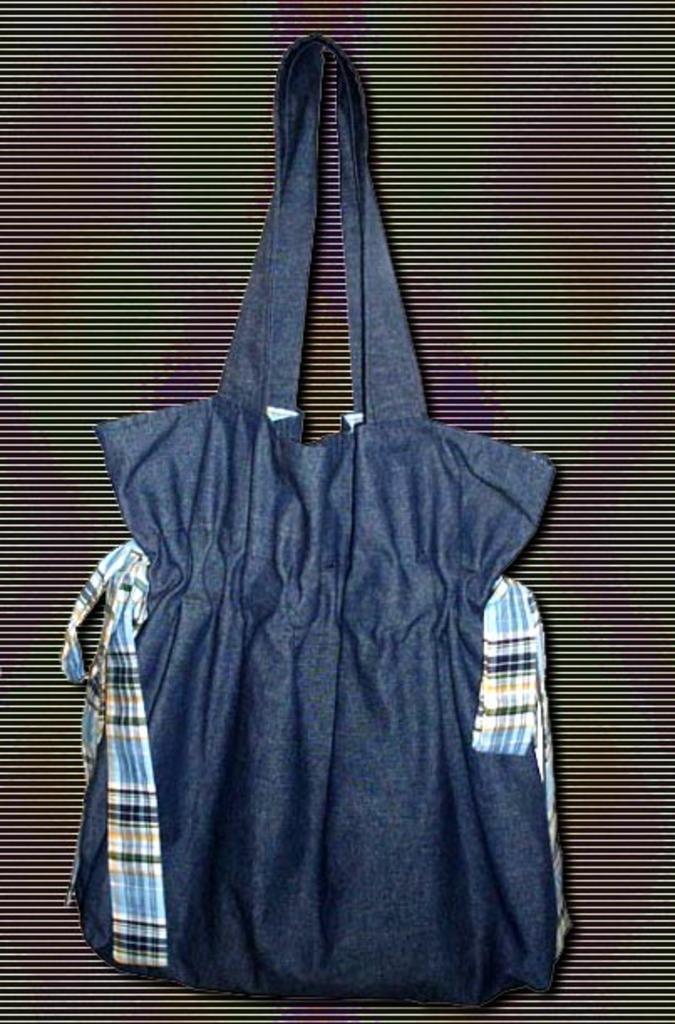Can you describe this image briefly? In the center of the image there is a blue color bag which is hanging on the wall. 